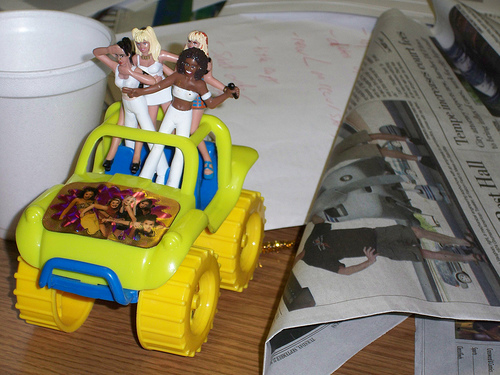<image>
Is the monster truck above the man? Yes. The monster truck is positioned above the man in the vertical space, higher up in the scene. 